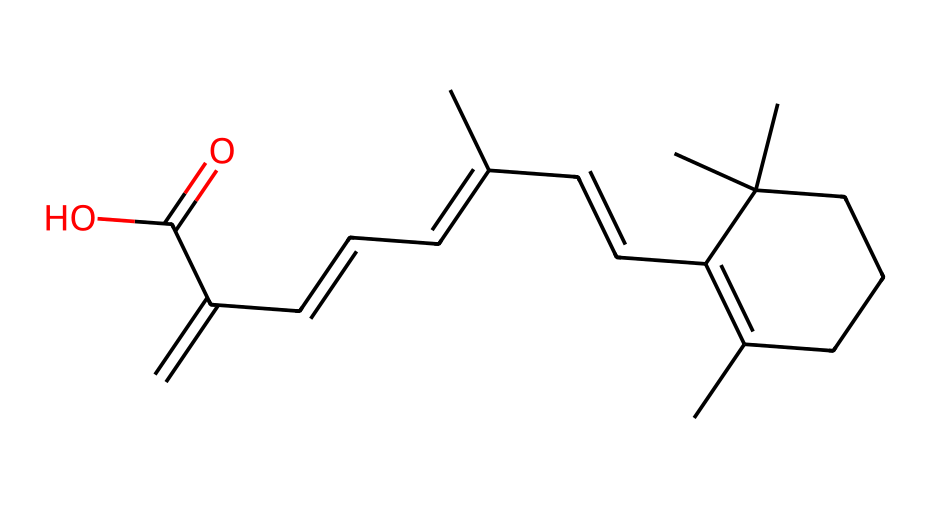What is the chemical name of the compound represented by the SMILES? The SMILES represents the compound known as retinol, which is a form of vitamin A used in various cosmetic formulations.
Answer: retinol How many double bonds are present in this chemical structure? By analyzing the SMILES, we notice several = signs indicating double bonds. Counting these gives four double bonds in total.
Answer: four What functional group is present at the end of this chemical structure? The SMILES provides an indication of a carboxylic acid functional group through the presence of -C(=O)O, which directly points to the acidic nature of the compound.
Answer: carboxylic acid How many carbon atoms are present in this chemical? We can systematically count the "C" characters within the SMILES notation, leading to a total count of 20 carbon atoms present in this compound.
Answer: twenty Describe the type of isomerism present in retinol. The structure features multiple configurations due to the presence of double bonds and stereocenters, leading to geometric (cis/trans) and optical isomerism.
Answer: geometric and optical Why is retinol significant in cosmetic formulations? Retinol is significant due to its ability to promote cell turnover and improve skin texture, which is crucial for anti-aging effects in cosmetic applications.
Answer: anti-aging What type of reaction might retinol undergo when exposed to oxygen? Retinol is prone to oxidation reactions when exposed to oxygen, which can degrade its efficacy; this susceptibility is due to its unsaturated double bonds.
Answer: oxidation 